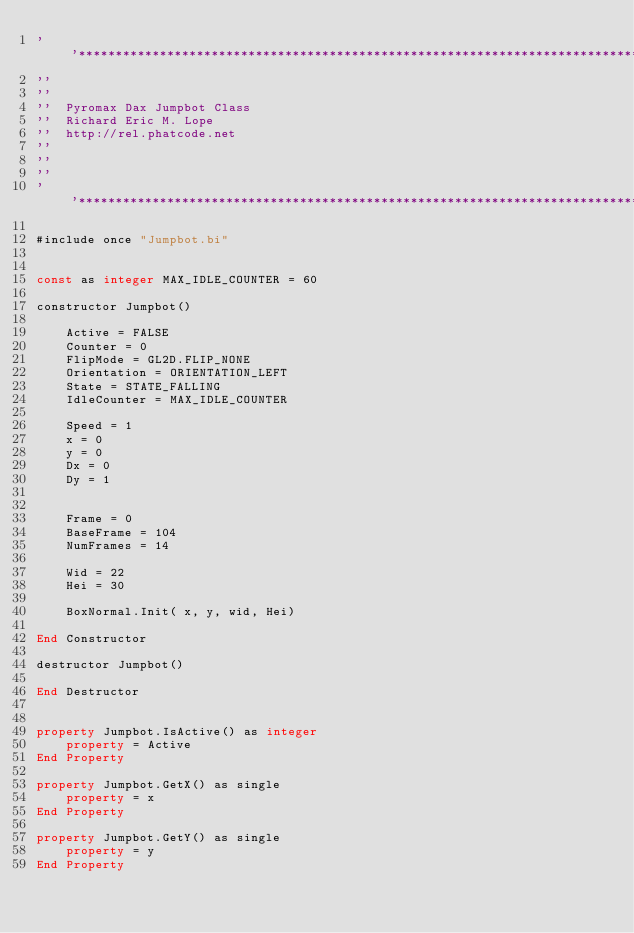<code> <loc_0><loc_0><loc_500><loc_500><_VisualBasic_>''*****************************************************************************
''
''
''	Pyromax Dax Jumpbot Class
''	Richard Eric M. Lope
''	http://rel.phatcode.net
''
''	
''
''*****************************************************************************

#include once "Jumpbot.bi"


const as integer MAX_IDLE_COUNTER = 60

constructor Jumpbot()

	Active = FALSE
	Counter = 0 
	FlipMode = GL2D.FLIP_NONE
	Orientation = ORIENTATION_LEFT
	State = STATE_FALLING
	IdleCounter = MAX_IDLE_COUNTER
		
	Speed = 1	
	x = 0
	y = 0
	Dx = 0
	Dy = 1
	

	Frame = 0
	BaseFrame = 104
	NumFrames = 14
	
	Wid = 22
	Hei	= 30
	
	BoxNormal.Init( x, y, wid, Hei)
	
End Constructor

destructor Jumpbot()

End Destructor


property Jumpbot.IsActive() as integer
	property = Active
End Property
		
property Jumpbot.GetX() as single
	property = x
End Property

property Jumpbot.GetY() as single
	property = y
End Property
</code> 